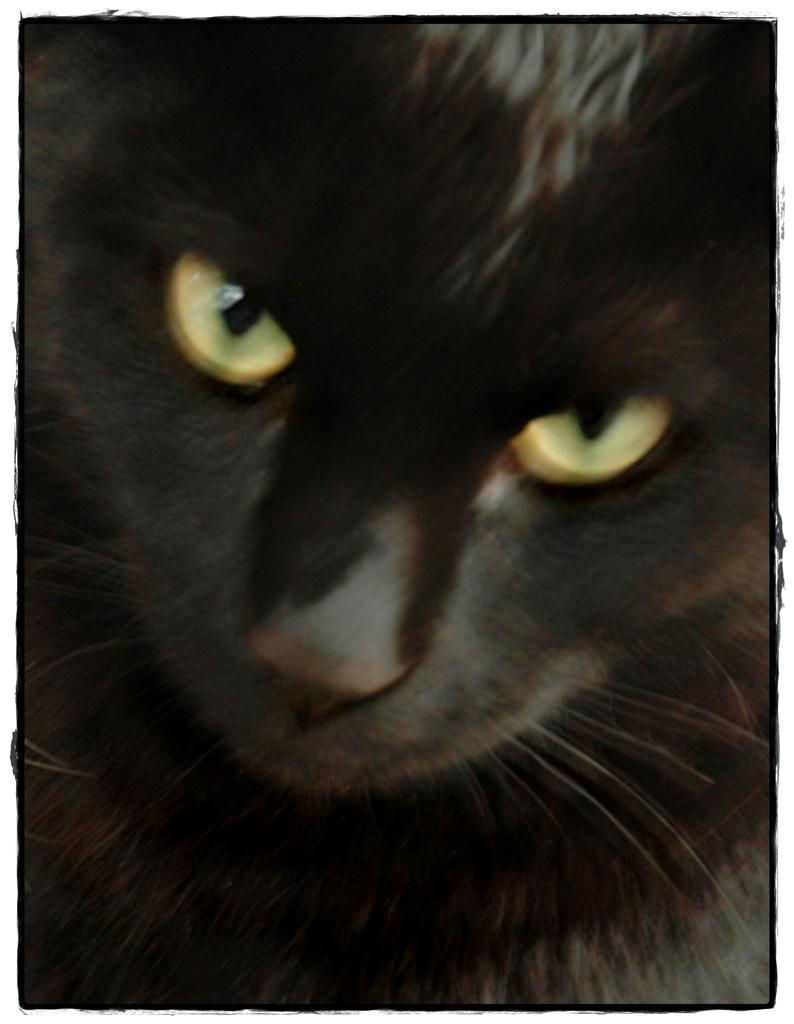What type of animal is in the image? There is a black cat in the image. What part of the cat can be seen in the image? The eyes of the cat are visible in the image. What type of silk material is being used by the pest in the image? There is no pest or silk material present in the image; it features a black cat with visible eyes. 